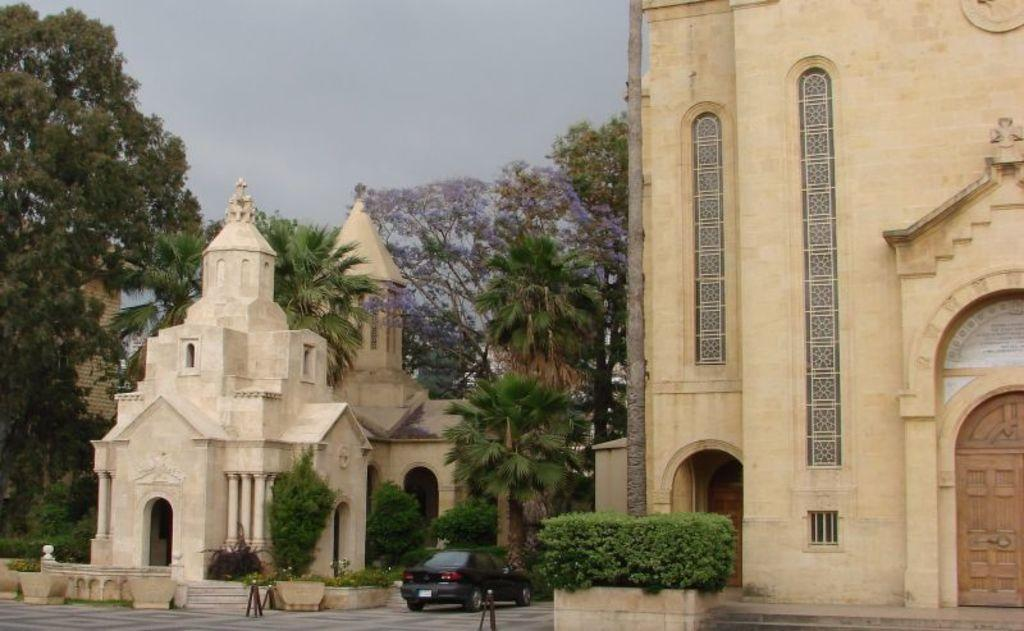What is on the ground in the image? There is a car on the ground in the image. What structures can be seen in the image besides the car? There are poles, concrete planters with plants, buildings, and trees in the image. What is visible in the background of the image? The sky is visible in the background of the image. How many geese are flying in the image? There are no geese visible in the image. What type of instrument is being played by the trees in the image? Trees do not play instruments; they are plants. 